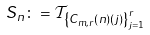<formula> <loc_0><loc_0><loc_500><loc_500>S _ { n } \colon = \mathcal { T } _ { \left \{ C _ { m , r } \left ( n \right ) \left ( j \right ) \right \} _ { j = 1 } ^ { r } }</formula> 